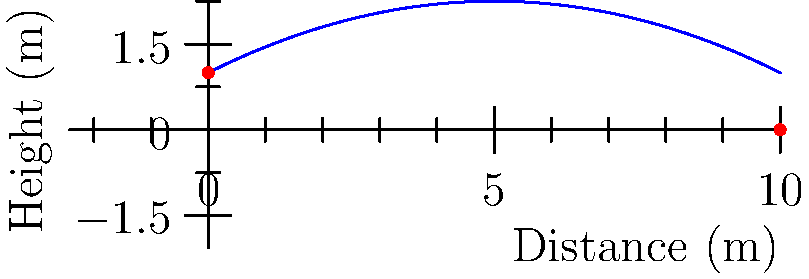A defenseman takes a slap shot from the blue line, launching the puck at an initial height of 1 meter. The trajectory of the puck can be modeled by the function $h(x) = -0.05x^2 + 0.5x + 1$, where $h$ is the height in meters and $x$ is the horizontal distance in meters. What is the maximum height reached by the puck during its flight? To find the maximum height of the puck's trajectory, we need to follow these steps:

1) The function describing the puck's path is $h(x) = -0.05x^2 + 0.5x + 1$

2) To find the maximum point, we need to find where the derivative of this function equals zero:
   $h'(x) = -0.1x + 0.5$

3) Set $h'(x) = 0$ and solve for $x$:
   $-0.1x + 0.5 = 0$
   $-0.1x = -0.5$
   $x = 5$

4) This x-value (5 meters) represents the horizontal distance at which the puck reaches its maximum height.

5) To find the maximum height, we plug this x-value back into our original function:
   $h(5) = -0.05(5^2) + 0.5(5) + 1$
   $= -0.05(25) + 2.5 + 1$
   $= -1.25 + 2.5 + 1$
   $= 2.25$

Therefore, the maximum height reached by the puck is 2.25 meters.
Answer: 2.25 meters 